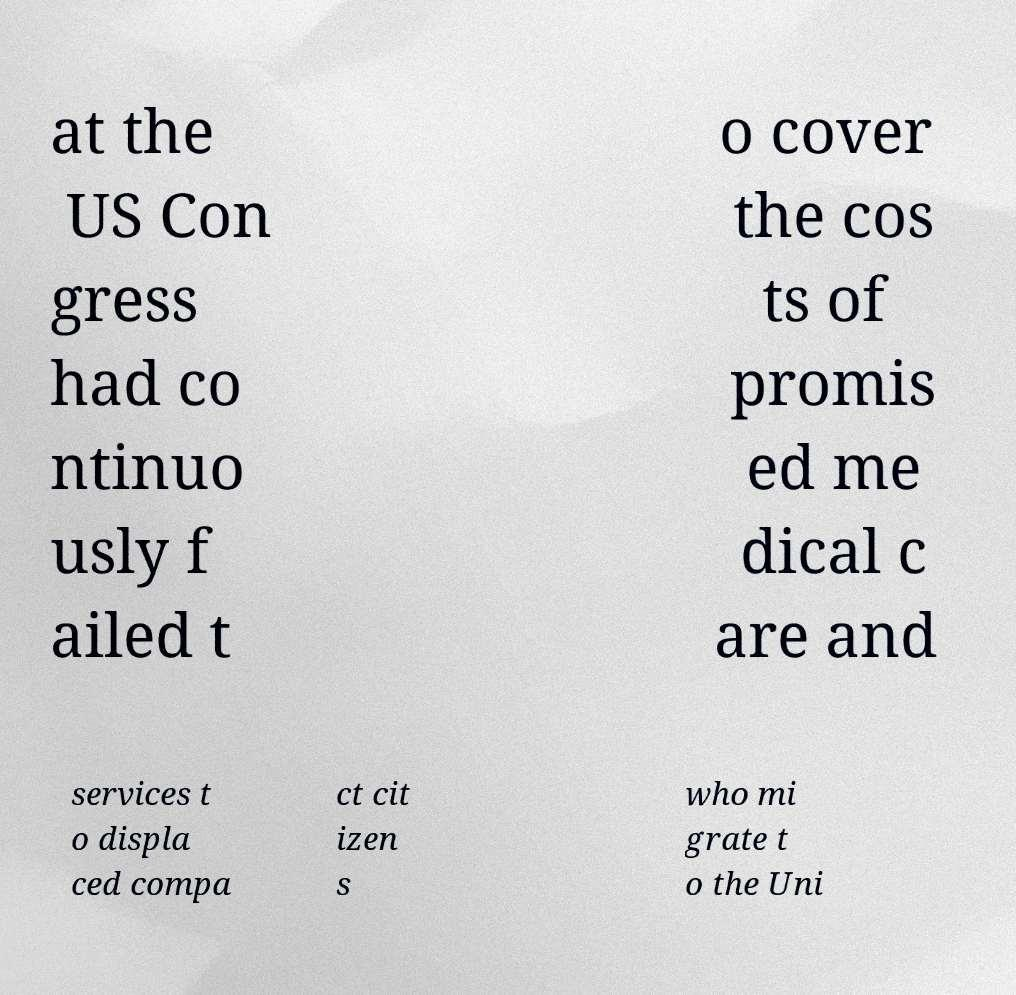I need the written content from this picture converted into text. Can you do that? at the US Con gress had co ntinuo usly f ailed t o cover the cos ts of promis ed me dical c are and services t o displa ced compa ct cit izen s who mi grate t o the Uni 